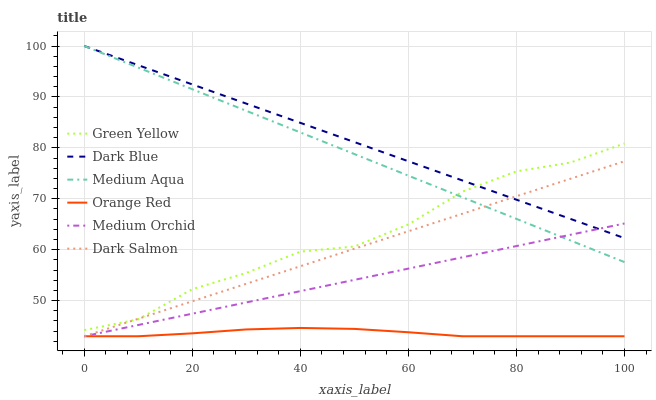Does Orange Red have the minimum area under the curve?
Answer yes or no. Yes. Does Dark Blue have the maximum area under the curve?
Answer yes or no. Yes. Does Dark Salmon have the minimum area under the curve?
Answer yes or no. No. Does Dark Salmon have the maximum area under the curve?
Answer yes or no. No. Is Dark Blue the smoothest?
Answer yes or no. Yes. Is Green Yellow the roughest?
Answer yes or no. Yes. Is Dark Salmon the smoothest?
Answer yes or no. No. Is Dark Salmon the roughest?
Answer yes or no. No. Does Medium Orchid have the lowest value?
Answer yes or no. Yes. Does Dark Blue have the lowest value?
Answer yes or no. No. Does Medium Aqua have the highest value?
Answer yes or no. Yes. Does Dark Salmon have the highest value?
Answer yes or no. No. Is Medium Orchid less than Green Yellow?
Answer yes or no. Yes. Is Medium Aqua greater than Orange Red?
Answer yes or no. Yes. Does Medium Aqua intersect Medium Orchid?
Answer yes or no. Yes. Is Medium Aqua less than Medium Orchid?
Answer yes or no. No. Is Medium Aqua greater than Medium Orchid?
Answer yes or no. No. Does Medium Orchid intersect Green Yellow?
Answer yes or no. No. 